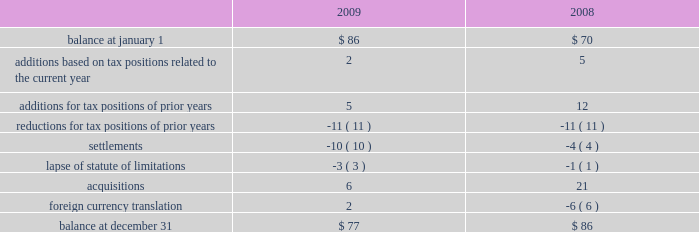At december 31 , 2009 , aon had domestic federal operating loss carryforwards of $ 7 million that will expire at various dates from 2010 to 2024 , state operating loss carryforwards of $ 513 million that will expire at various dates from 2010 to 2028 , and foreign operating and capital loss carryforwards of $ 453 million and $ 252 million , respectively , nearly all of which are subject to indefinite carryforward .
Unrecognized tax benefits the following is a reconciliation of the company 2019s beginning and ending amount of unrecognized tax benefits ( in millions ) : .
As of december 31 , 2009 , $ 61 million of unrecognized tax benefits would impact the effective tax rate if recognized .
Aon does not expect the unrecognized tax positions to change significantly over the next twelve months .
The company recognizes penalties and interest related to unrecognized income tax benefits in its provision for income taxes .
Aon accrued potential penalties of less than $ 1 million during each of 2009 , 2008 and 2007 .
Aon accrued interest of $ 2 million during 2009 and less than $ 1 million during both 2008 and 2007 .
As of december 31 , 2009 and 2008 , aon has recorded a liability for penalties of $ 5 million and $ 4 million , respectively , and for interest of $ 18 million and $ 14 million , respectively .
Aon and its subsidiaries file income tax returns in the u.s .
Federal jurisdiction as well as various state and international jurisdictions .
Aon has substantially concluded all u.s .
Federal income tax matters for years through 2006 .
Material u.s .
State and local income tax jurisdiction examinations have been concluded for years through 2002 .
Aon has concluded income tax examinations in its primary international jurisdictions through 2002. .
In 2009 what was the ratio of the interest to the liability? 
Rationale: in 2009 there was 3.6 times of interest to the liabilities for penalties
Computations: (18 / 5)
Answer: 3.6. 